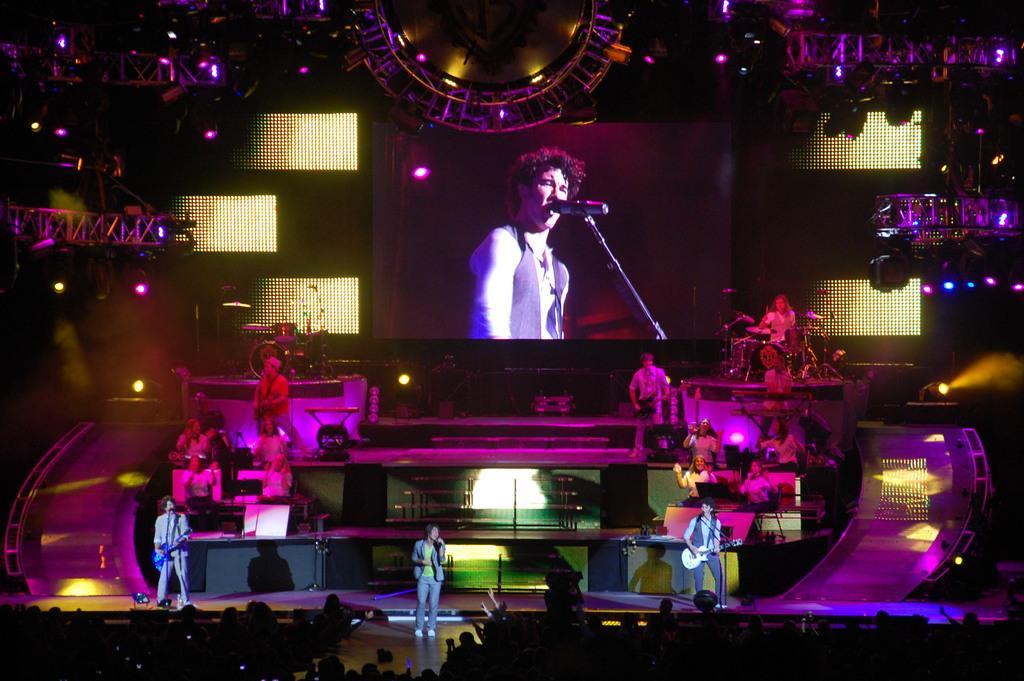Please provide a concise description of this image. In this image I can see many people in the front. A person is standing in the center and holding a microphone. Other people are playing musical instruments. There are lights and a projector display at the back. 